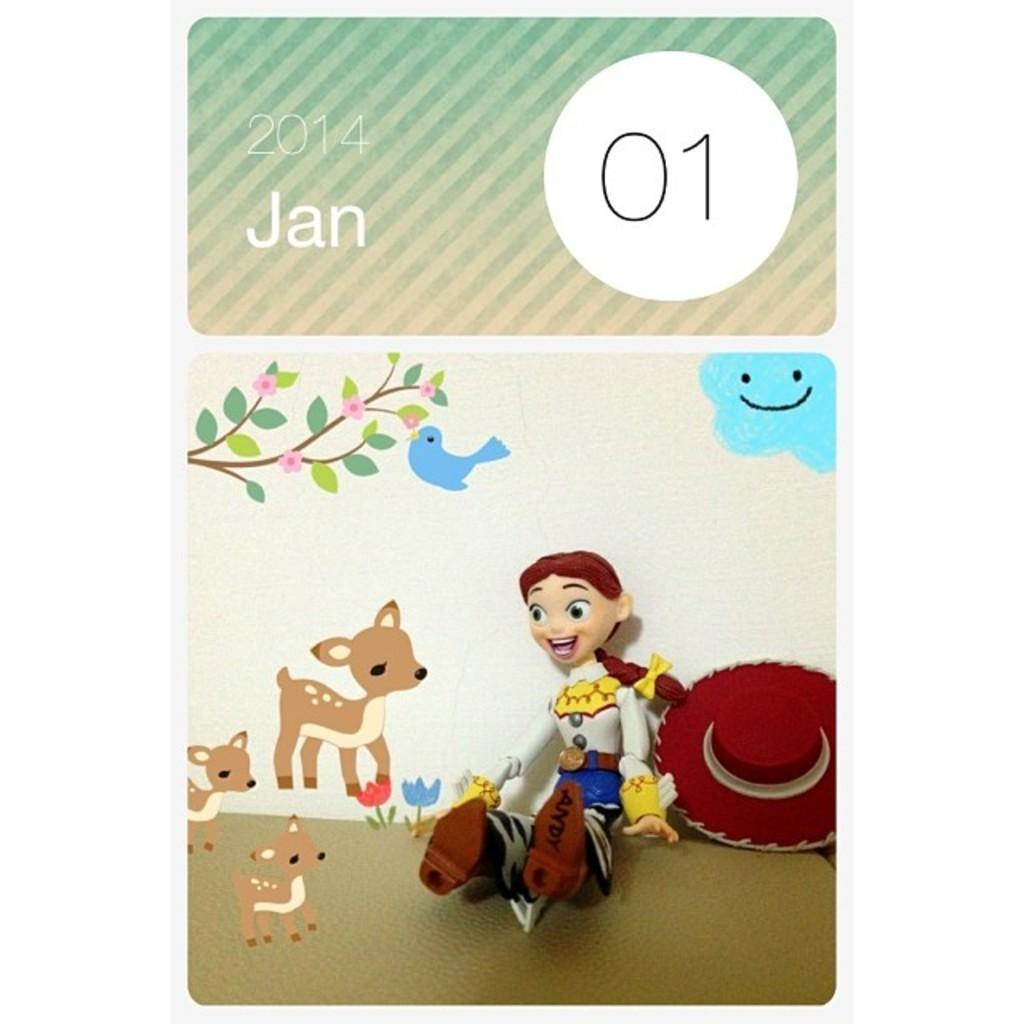How would you summarize this image in a sentence or two? In this picture we can see a poster, there are cartoon images of deer, a person and a cap at the bottom, on the left side there is a bird, a branch of a tree and flowers, we can see some text and numbers at the top of the picture. 